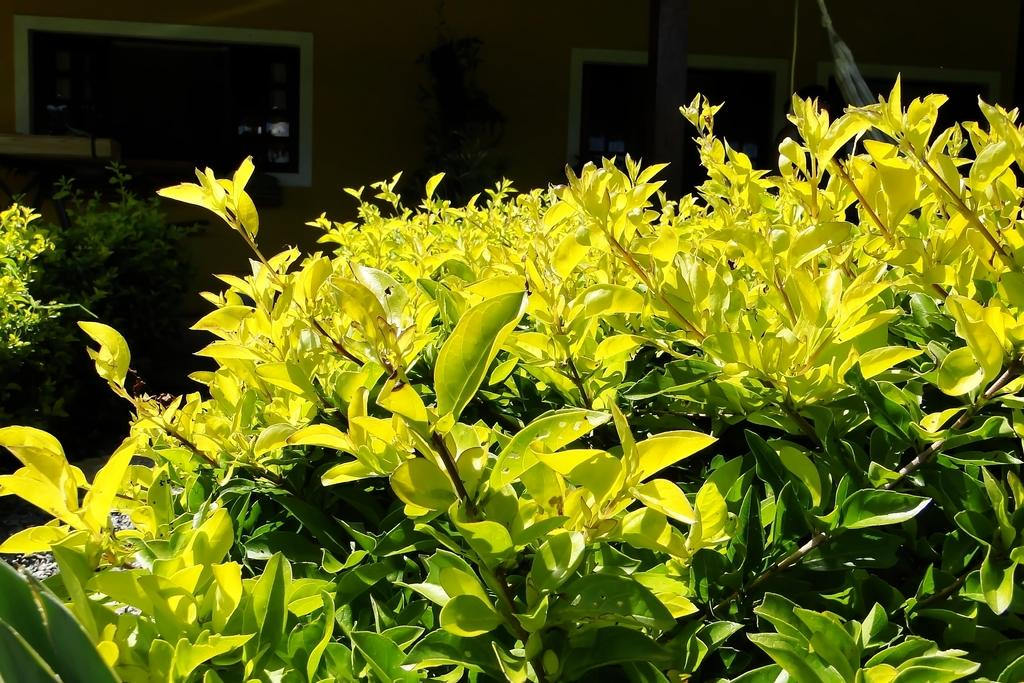What type of vegetation is visible in the front of the image? There are plants in the front of the image. What can be seen in the background of the image? There is a wall and glass windows in the background of the image. Can you see the moon in the image? There is no moon visible in the image; it only features plants, a wall, and glass windows. Is there a mountain visible in the image? There is no mountain present in the image. 